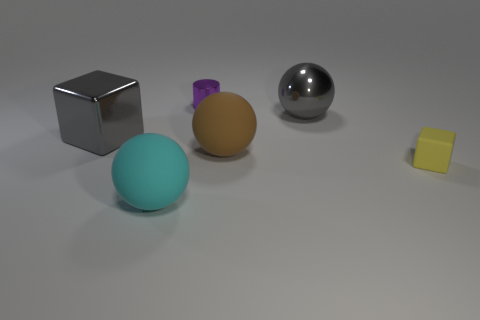Subtract all large brown spheres. How many spheres are left? 2 Subtract all gray spheres. How many spheres are left? 2 Add 1 gray spheres. How many objects exist? 7 Subtract all blocks. How many objects are left? 4 Subtract 1 cubes. How many cubes are left? 1 Subtract all gray balls. How many yellow blocks are left? 1 Subtract all large gray blocks. Subtract all metal balls. How many objects are left? 4 Add 3 matte blocks. How many matte blocks are left? 4 Add 2 yellow blocks. How many yellow blocks exist? 3 Subtract 0 green cubes. How many objects are left? 6 